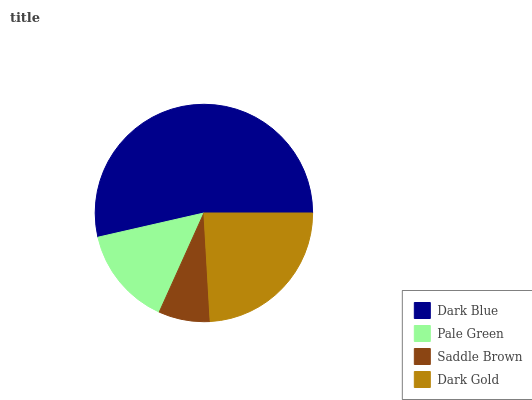Is Saddle Brown the minimum?
Answer yes or no. Yes. Is Dark Blue the maximum?
Answer yes or no. Yes. Is Pale Green the minimum?
Answer yes or no. No. Is Pale Green the maximum?
Answer yes or no. No. Is Dark Blue greater than Pale Green?
Answer yes or no. Yes. Is Pale Green less than Dark Blue?
Answer yes or no. Yes. Is Pale Green greater than Dark Blue?
Answer yes or no. No. Is Dark Blue less than Pale Green?
Answer yes or no. No. Is Dark Gold the high median?
Answer yes or no. Yes. Is Pale Green the low median?
Answer yes or no. Yes. Is Saddle Brown the high median?
Answer yes or no. No. Is Saddle Brown the low median?
Answer yes or no. No. 